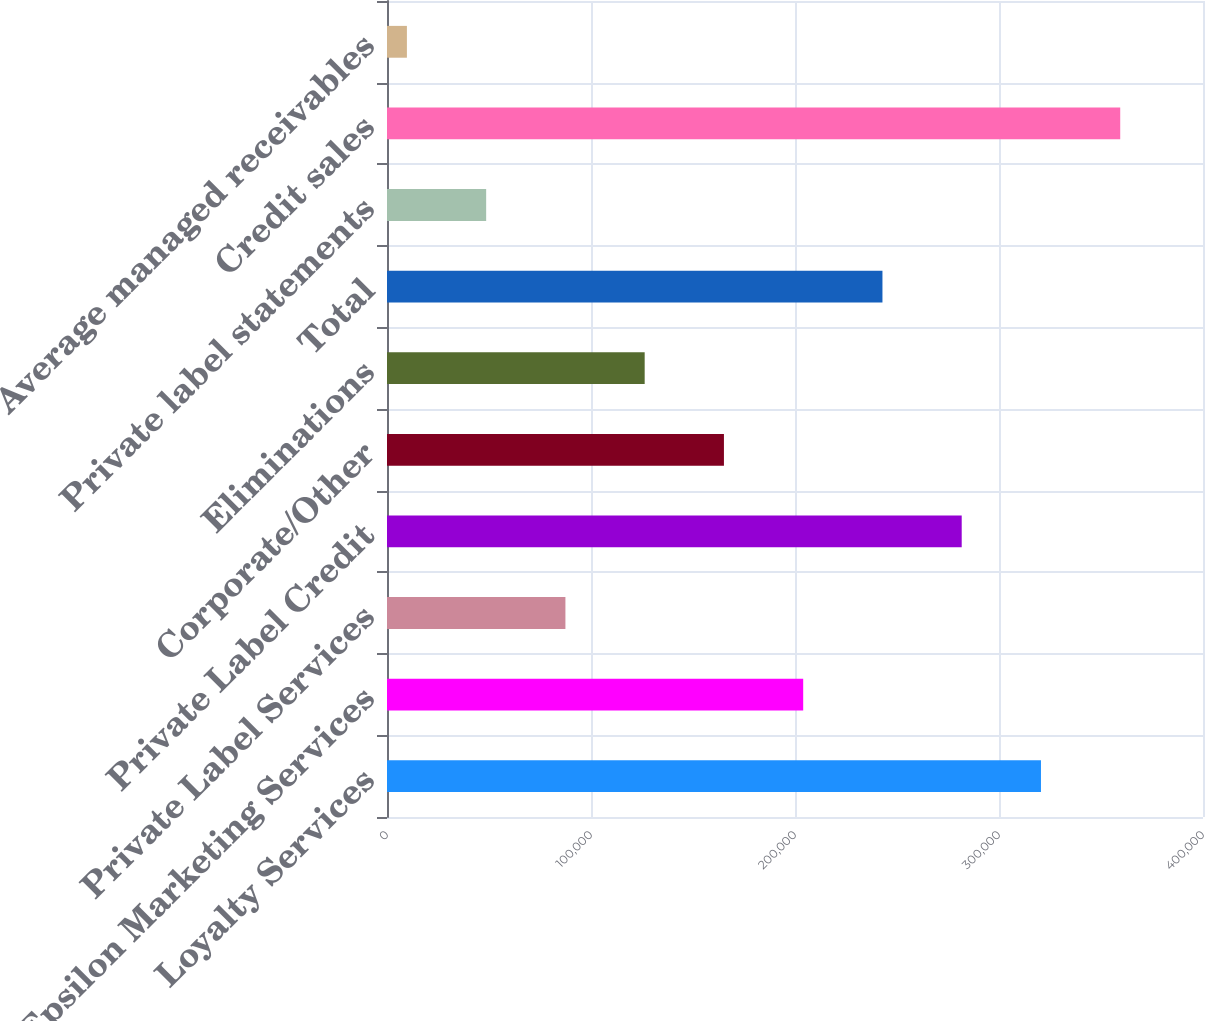Convert chart to OTSL. <chart><loc_0><loc_0><loc_500><loc_500><bar_chart><fcel>Loyalty Services<fcel>Epsilon Marketing Services<fcel>Private Label Services<fcel>Private Label Credit<fcel>Corporate/Other<fcel>Eliminations<fcel>Total<fcel>Private label statements<fcel>Credit sales<fcel>Average managed receivables<nl><fcel>320572<fcel>204016<fcel>87461.4<fcel>281720<fcel>165165<fcel>126313<fcel>242868<fcel>48609.7<fcel>359423<fcel>9758<nl></chart> 